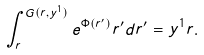<formula> <loc_0><loc_0><loc_500><loc_500>\int _ { r } ^ { G ( r , y ^ { 1 } ) } e ^ { \Phi ( r ^ { \prime } ) } r ^ { \prime } d r ^ { \prime } = y ^ { 1 } r .</formula> 